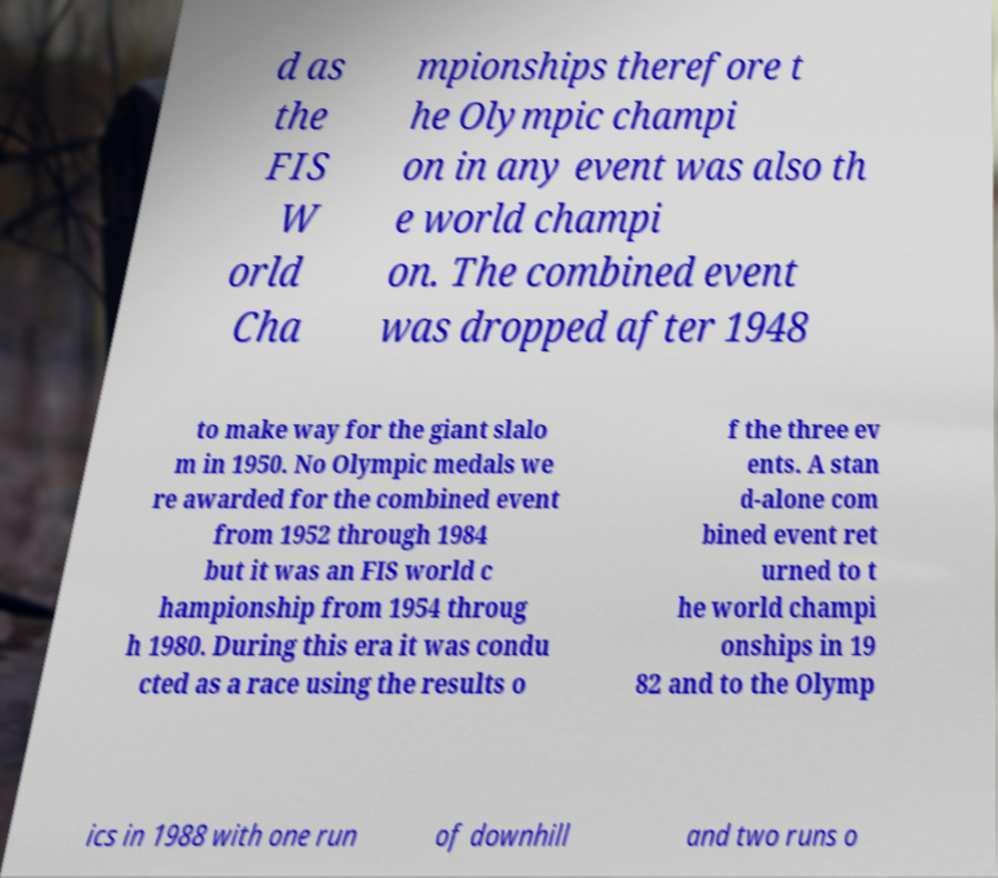Could you assist in decoding the text presented in this image and type it out clearly? d as the FIS W orld Cha mpionships therefore t he Olympic champi on in any event was also th e world champi on. The combined event was dropped after 1948 to make way for the giant slalo m in 1950. No Olympic medals we re awarded for the combined event from 1952 through 1984 but it was an FIS world c hampionship from 1954 throug h 1980. During this era it was condu cted as a race using the results o f the three ev ents. A stan d-alone com bined event ret urned to t he world champi onships in 19 82 and to the Olymp ics in 1988 with one run of downhill and two runs o 